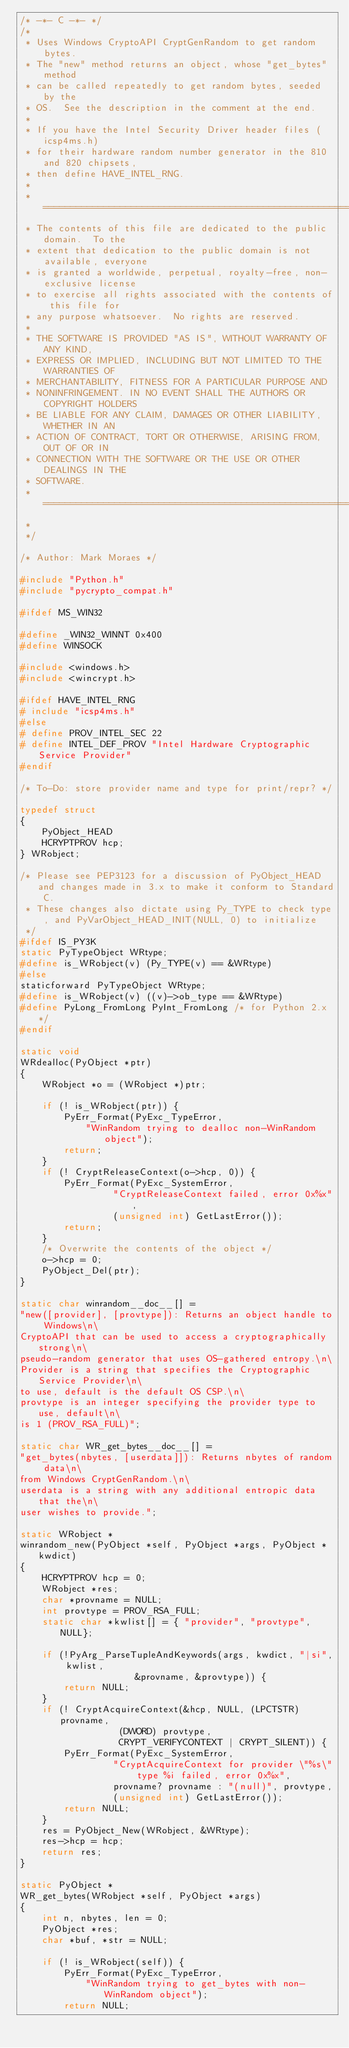<code> <loc_0><loc_0><loc_500><loc_500><_C_>/* -*- C -*- */
/*
 * Uses Windows CryptoAPI CryptGenRandom to get random bytes.
 * The "new" method returns an object, whose "get_bytes" method
 * can be called repeatedly to get random bytes, seeded by the
 * OS.  See the description in the comment at the end.
 * 
 * If you have the Intel Security Driver header files (icsp4ms.h)
 * for their hardware random number generator in the 810 and 820 chipsets,
 * then define HAVE_INTEL_RNG.
 *
 * =======================================================================
 * The contents of this file are dedicated to the public domain.  To the
 * extent that dedication to the public domain is not available, everyone
 * is granted a worldwide, perpetual, royalty-free, non-exclusive license
 * to exercise all rights associated with the contents of this file for
 * any purpose whatsoever.  No rights are reserved.
 *
 * THE SOFTWARE IS PROVIDED "AS IS", WITHOUT WARRANTY OF ANY KIND,
 * EXPRESS OR IMPLIED, INCLUDING BUT NOT LIMITED TO THE WARRANTIES OF
 * MERCHANTABILITY, FITNESS FOR A PARTICULAR PURPOSE AND
 * NONINFRINGEMENT. IN NO EVENT SHALL THE AUTHORS OR COPYRIGHT HOLDERS
 * BE LIABLE FOR ANY CLAIM, DAMAGES OR OTHER LIABILITY, WHETHER IN AN
 * ACTION OF CONTRACT, TORT OR OTHERWISE, ARISING FROM, OUT OF OR IN
 * CONNECTION WITH THE SOFTWARE OR THE USE OR OTHER DEALINGS IN THE
 * SOFTWARE.
 * =======================================================================
 *
 */

/* Author: Mark Moraes */

#include "Python.h"
#include "pycrypto_compat.h"

#ifdef MS_WIN32

#define _WIN32_WINNT 0x400
#define WINSOCK

#include <windows.h>
#include <wincrypt.h>

#ifdef HAVE_INTEL_RNG
# include "icsp4ms.h"
#else
# define PROV_INTEL_SEC 22
# define INTEL_DEF_PROV "Intel Hardware Cryptographic Service Provider"
#endif

/* To-Do: store provider name and type for print/repr? */

typedef struct
{
    PyObject_HEAD
    HCRYPTPROV hcp;
} WRobject;

/* Please see PEP3123 for a discussion of PyObject_HEAD and changes made in 3.x to make it conform to Standard C.
 * These changes also dictate using Py_TYPE to check type, and PyVarObject_HEAD_INIT(NULL, 0) to initialize
 */
#ifdef IS_PY3K
static PyTypeObject WRtype;
#define is_WRobject(v) (Py_TYPE(v) == &WRtype)
#else
staticforward PyTypeObject WRtype;
#define is_WRobject(v) ((v)->ob_type == &WRtype)
#define PyLong_FromLong PyInt_FromLong /* for Python 2.x */
#endif

static void
WRdealloc(PyObject *ptr)
{		
	WRobject *o = (WRobject *)ptr;

	if (! is_WRobject(ptr)) {
		PyErr_Format(PyExc_TypeError,
		    "WinRandom trying to dealloc non-WinRandom object");
		return;
	}
	if (! CryptReleaseContext(o->hcp, 0)) {
		PyErr_Format(PyExc_SystemError,
			     "CryptReleaseContext failed, error 0x%x",
			     (unsigned int) GetLastError());
		return;
	}
	/* Overwrite the contents of the object */
	o->hcp = 0;
	PyObject_Del(ptr);
}

static char winrandom__doc__[] =
"new([provider], [provtype]): Returns an object handle to Windows\n\
CryptoAPI that can be used to access a cryptographically strong\n\
pseudo-random generator that uses OS-gathered entropy.\n\
Provider is a string that specifies the Cryptographic Service Provider\n\
to use, default is the default OS CSP.\n\
provtype is an integer specifying the provider type to use, default\n\
is 1 (PROV_RSA_FULL)";

static char WR_get_bytes__doc__[] =
"get_bytes(nbytes, [userdata]]): Returns nbytes of random data\n\
from Windows CryptGenRandom.\n\
userdata is a string with any additional entropic data that the\n\
user wishes to provide.";

static WRobject *
winrandom_new(PyObject *self, PyObject *args, PyObject *kwdict)
{
	HCRYPTPROV hcp = 0;
	WRobject *res;
	char *provname = NULL;
	int provtype = PROV_RSA_FULL;
	static char *kwlist[] = { "provider", "provtype", NULL};
	
	if (!PyArg_ParseTupleAndKeywords(args, kwdict, "|si", kwlist,
					 &provname, &provtype)) {
		return NULL;
	}
	if (! CryptAcquireContext(&hcp, NULL, (LPCTSTR) provname,
				  (DWORD) provtype,
				  CRYPT_VERIFYCONTEXT | CRYPT_SILENT)) {
		PyErr_Format(PyExc_SystemError,
			     "CryptAcquireContext for provider \"%s\" type %i failed, error 0x%x",
			     provname? provname : "(null)", provtype,
			     (unsigned int) GetLastError());
		return NULL;
	}
	res = PyObject_New(WRobject, &WRtype);
	res->hcp = hcp;
	return res;
}

static PyObject *
WR_get_bytes(WRobject *self, PyObject *args)
{
	int n, nbytes, len = 0;
	PyObject *res;
	char *buf, *str = NULL;
	
	if (! is_WRobject(self)) {
		PyErr_Format(PyExc_TypeError,
		    "WinRandom trying to get_bytes with non-WinRandom object");
		return NULL;</code> 